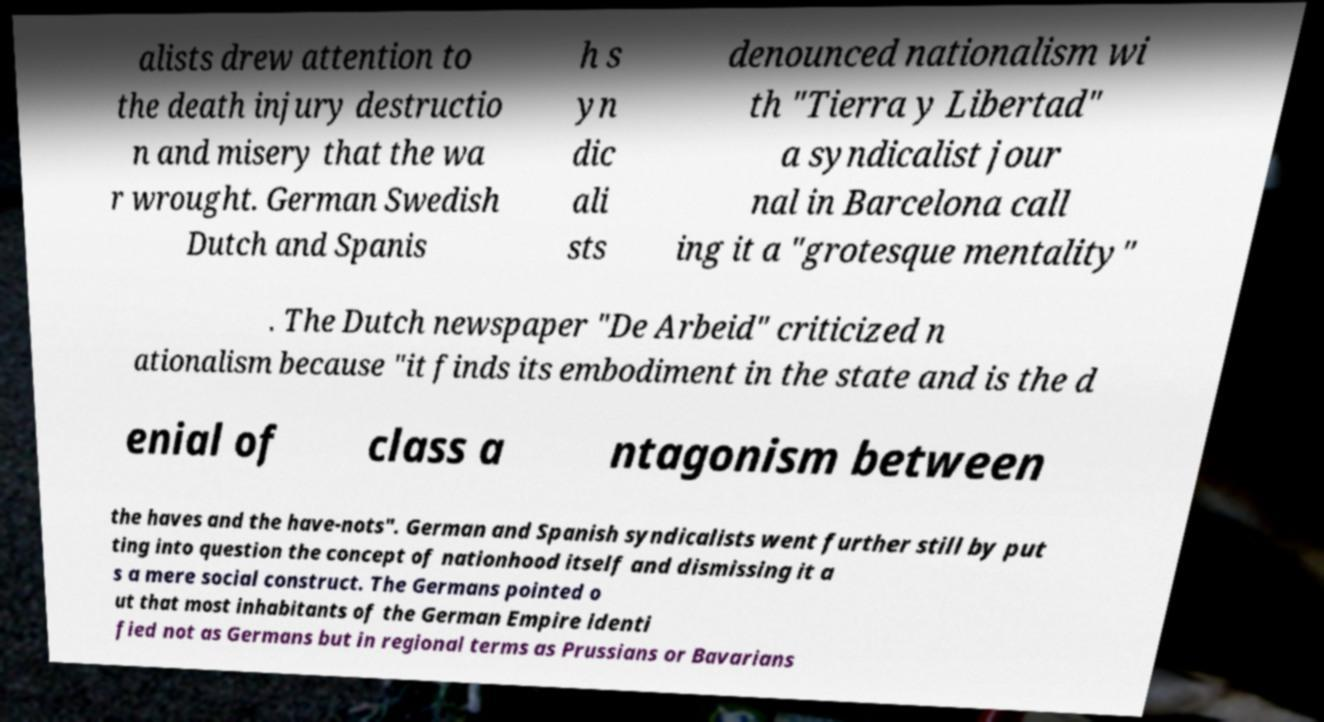Could you extract and type out the text from this image? alists drew attention to the death injury destructio n and misery that the wa r wrought. German Swedish Dutch and Spanis h s yn dic ali sts denounced nationalism wi th "Tierra y Libertad" a syndicalist jour nal in Barcelona call ing it a "grotesque mentality" . The Dutch newspaper "De Arbeid" criticized n ationalism because "it finds its embodiment in the state and is the d enial of class a ntagonism between the haves and the have-nots". German and Spanish syndicalists went further still by put ting into question the concept of nationhood itself and dismissing it a s a mere social construct. The Germans pointed o ut that most inhabitants of the German Empire identi fied not as Germans but in regional terms as Prussians or Bavarians 